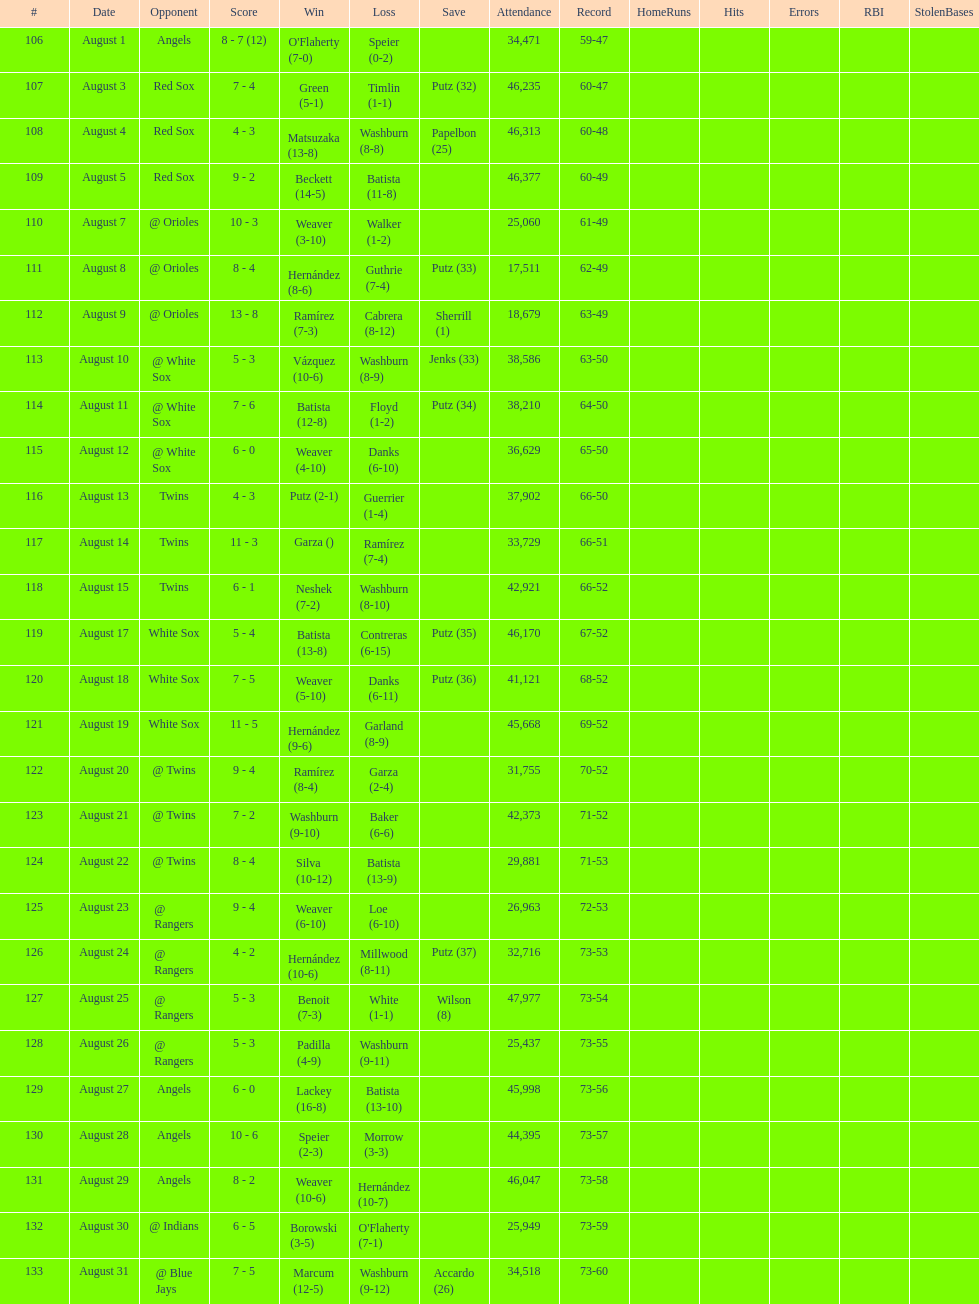Largest run differential 8. Parse the table in full. {'header': ['#', 'Date', 'Opponent', 'Score', 'Win', 'Loss', 'Save', 'Attendance', 'Record', 'HomeRuns', 'Hits', 'Errors', 'RBI', 'StolenBases'], 'rows': [['106', 'August 1', 'Angels', '8 - 7 (12)', "O'Flaherty (7-0)", 'Speier (0-2)', '', '34,471', '59-47', '', '', '', '', ''], ['107', 'August 3', 'Red Sox', '7 - 4', 'Green (5-1)', 'Timlin (1-1)', 'Putz (32)', '46,235', '60-47', '', '', '', '', ''], ['108', 'August 4', 'Red Sox', '4 - 3', 'Matsuzaka (13-8)', 'Washburn (8-8)', 'Papelbon (25)', '46,313', '60-48', '', '', '', '', ''], ['109', 'August 5', 'Red Sox', '9 - 2', 'Beckett (14-5)', 'Batista (11-8)', '', '46,377', '60-49', '', '', '', '', ''], ['110', 'August 7', '@ Orioles', '10 - 3', 'Weaver (3-10)', 'Walker (1-2)', '', '25,060', '61-49', '', '', '', '', ''], ['111', 'August 8', '@ Orioles', '8 - 4', 'Hernández (8-6)', 'Guthrie (7-4)', 'Putz (33)', '17,511', '62-49', '', '', '', '', ''], ['112', 'August 9', '@ Orioles', '13 - 8', 'Ramírez (7-3)', 'Cabrera (8-12)', 'Sherrill (1)', '18,679', '63-49', '', '', '', '', ''], ['113', 'August 10', '@ White Sox', '5 - 3', 'Vázquez (10-6)', 'Washburn (8-9)', 'Jenks (33)', '38,586', '63-50', '', '', '', '', ''], ['114', 'August 11', '@ White Sox', '7 - 6', 'Batista (12-8)', 'Floyd (1-2)', 'Putz (34)', '38,210', '64-50', '', '', '', '', ''], ['115', 'August 12', '@ White Sox', '6 - 0', 'Weaver (4-10)', 'Danks (6-10)', '', '36,629', '65-50', '', '', '', '', ''], ['116', 'August 13', 'Twins', '4 - 3', 'Putz (2-1)', 'Guerrier (1-4)', '', '37,902', '66-50', '', '', '', '', ''], ['117', 'August 14', 'Twins', '11 - 3', 'Garza ()', 'Ramírez (7-4)', '', '33,729', '66-51', '', '', '', '', ''], ['118', 'August 15', 'Twins', '6 - 1', 'Neshek (7-2)', 'Washburn (8-10)', '', '42,921', '66-52', '', '', '', '', ''], ['119', 'August 17', 'White Sox', '5 - 4', 'Batista (13-8)', 'Contreras (6-15)', 'Putz (35)', '46,170', '67-52', '', '', '', '', ''], ['120', 'August 18', 'White Sox', '7 - 5', 'Weaver (5-10)', 'Danks (6-11)', 'Putz (36)', '41,121', '68-52', '', '', '', '', ''], ['121', 'August 19', 'White Sox', '11 - 5', 'Hernández (9-6)', 'Garland (8-9)', '', '45,668', '69-52', '', '', '', '', ''], ['122', 'August 20', '@ Twins', '9 - 4', 'Ramírez (8-4)', 'Garza (2-4)', '', '31,755', '70-52', '', '', '', '', ''], ['123', 'August 21', '@ Twins', '7 - 2', 'Washburn (9-10)', 'Baker (6-6)', '', '42,373', '71-52', '', '', '', '', ''], ['124', 'August 22', '@ Twins', '8 - 4', 'Silva (10-12)', 'Batista (13-9)', '', '29,881', '71-53', '', '', '', '', ''], ['125', 'August 23', '@ Rangers', '9 - 4', 'Weaver (6-10)', 'Loe (6-10)', '', '26,963', '72-53', '', '', '', '', ''], ['126', 'August 24', '@ Rangers', '4 - 2', 'Hernández (10-6)', 'Millwood (8-11)', 'Putz (37)', '32,716', '73-53', '', '', '', '', ''], ['127', 'August 25', '@ Rangers', '5 - 3', 'Benoit (7-3)', 'White (1-1)', 'Wilson (8)', '47,977', '73-54', '', '', '', '', ''], ['128', 'August 26', '@ Rangers', '5 - 3', 'Padilla (4-9)', 'Washburn (9-11)', '', '25,437', '73-55', '', '', '', '', ''], ['129', 'August 27', 'Angels', '6 - 0', 'Lackey (16-8)', 'Batista (13-10)', '', '45,998', '73-56', '', '', '', '', ''], ['130', 'August 28', 'Angels', '10 - 6', 'Speier (2-3)', 'Morrow (3-3)', '', '44,395', '73-57', '', '', '', '', ''], ['131', 'August 29', 'Angels', '8 - 2', 'Weaver (10-6)', 'Hernández (10-7)', '', '46,047', '73-58', '', '', '', '', ''], ['132', 'August 30', '@ Indians', '6 - 5', 'Borowski (3-5)', "O'Flaherty (7-1)", '', '25,949', '73-59', '', '', '', '', ''], ['133', 'August 31', '@ Blue Jays', '7 - 5', 'Marcum (12-5)', 'Washburn (9-12)', 'Accardo (26)', '34,518', '73-60', '', '', '', '', '']]} 